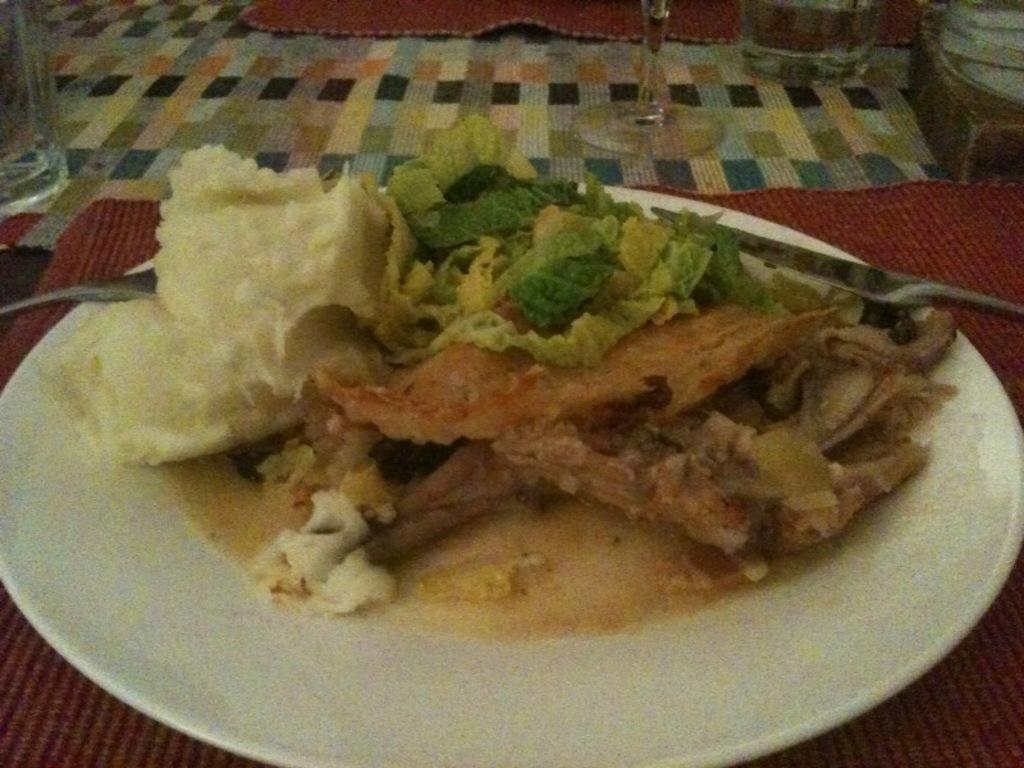In one or two sentences, can you explain what this image depicts? In this picture there is a plate in the center of the image, which contains food items and there are glasses at the top side of the image. 